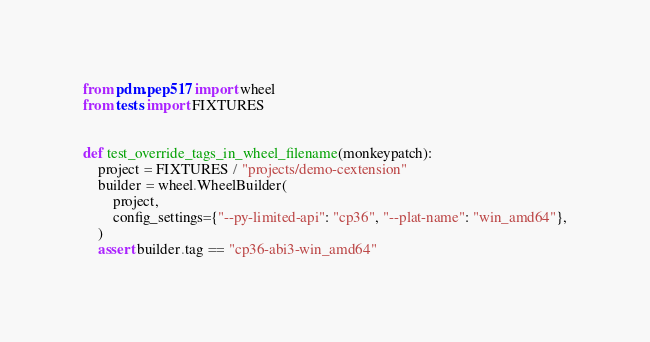Convert code to text. <code><loc_0><loc_0><loc_500><loc_500><_Python_>from pdm.pep517 import wheel
from tests import FIXTURES


def test_override_tags_in_wheel_filename(monkeypatch):
    project = FIXTURES / "projects/demo-cextension"
    builder = wheel.WheelBuilder(
        project,
        config_settings={"--py-limited-api": "cp36", "--plat-name": "win_amd64"},
    )
    assert builder.tag == "cp36-abi3-win_amd64"
</code> 